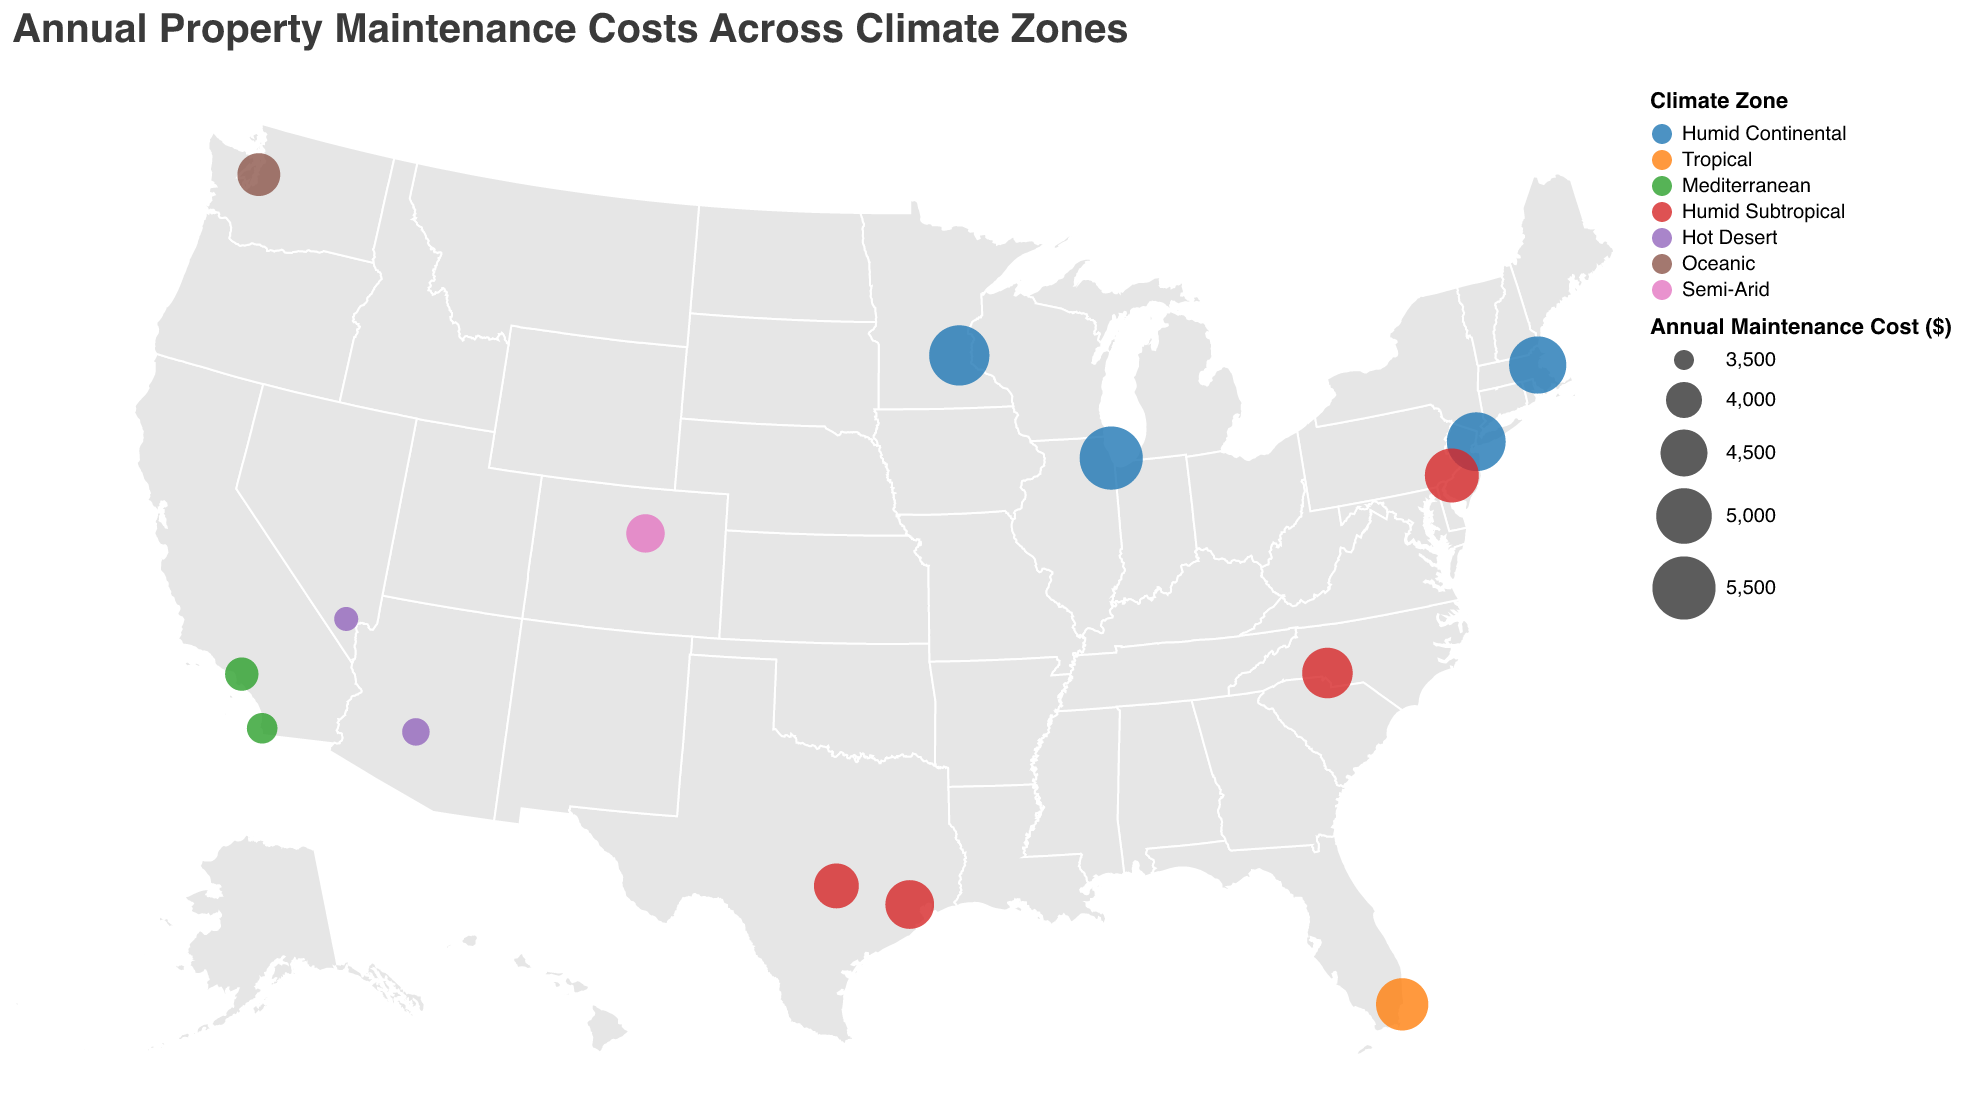What is the title of the figure? The title is usually displayed prominently at the top of the figure. By looking at the visual, we can see the sentence summarizing the data displayed.
Answer: Annual Property Maintenance Costs Across Climate Zones How many climate zones are represented on the map? Each climate zone is assigned a distinct color, which can be counted from the legend provided in the figure.
Answer: 7 Which city has the highest annual maintenance cost? Look for the largest circle on the map since the size of the circles represents the annual maintenance cost. The tooltip or the size legend can help verify the exact value.
Answer: Chicago Which climate zone is represented by the most cities? Count the number of cities corresponding to each color in the legend and determine which color appears the most frequently on the map
Answer: Humid Subtropical What is the difference in maintenance costs between the cities with the highest and lowest costs? Identify the cities with the highest and lowest maintenance costs by comparing the size of the circles, then subtract the smallest cost from the largest one.
Answer: 5500 - 3600 = 1900 Which city in the Mediterranean climate zone has the lower maintenance cost? Identify the cities within the Mediterranean climate zone by their color, and then compare the sizes of the circles representing each city.
Answer: San Diego What is the climate zone of New York City? Use the tooltip by hovering over the circle representing New York City to read its details or check the color corresponding to New York City and match it with the legend.
Answer: Humid Continental How does the average maintenance cost in Humid Subtropical zones compare to Tropical zones? Calculate the average maintenance cost for cities within each climate zone by adding the maintenance costs and then dividing by the number of cities in each zone, then compare the two averages.
Answer: Humid Subtropical: (4600 + 4900 + 4400 + 4700) / 4 = 4650, Tropical: 4800, so 4650 < 4800 What is the range of the annual maintenance costs among the cities shown on the map? Identify the highest and lowest maintenance costs by comparing the sizes of the circles, then subtract the smallest value from the largest value.
Answer: 5500 - 3600 = 1900 